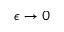<formula> <loc_0><loc_0><loc_500><loc_500>\epsilon \to 0</formula> 